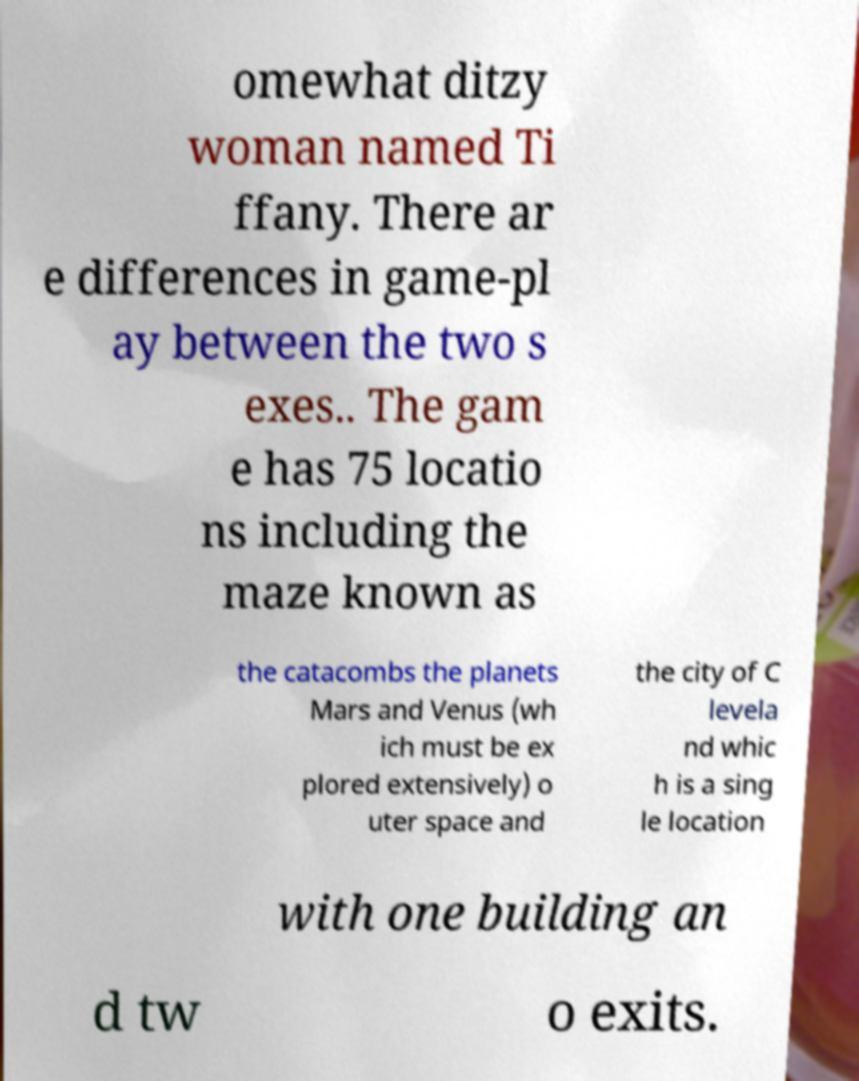Could you assist in decoding the text presented in this image and type it out clearly? omewhat ditzy woman named Ti ffany. There ar e differences in game-pl ay between the two s exes.. The gam e has 75 locatio ns including the maze known as the catacombs the planets Mars and Venus (wh ich must be ex plored extensively) o uter space and the city of C levela nd whic h is a sing le location with one building an d tw o exits. 